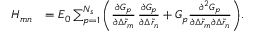Convert formula to latex. <formula><loc_0><loc_0><loc_500><loc_500>\begin{array} { r l } { H _ { m n } } & { = E _ { 0 } \sum _ { p = 1 } ^ { N _ { s } } { \left ( \frac { \partial G _ { p } } { \partial \Delta \tilde { r } _ { m } } \, \frac { \partial G _ { p } } { \partial \Delta \tilde { r } _ { n } } + G _ { p } \frac { \partial ^ { 2 } G _ { p } } { \partial \Delta \tilde { r } _ { m } \partial \Delta \tilde { r } _ { n } } \right ) } . } \end{array}</formula> 